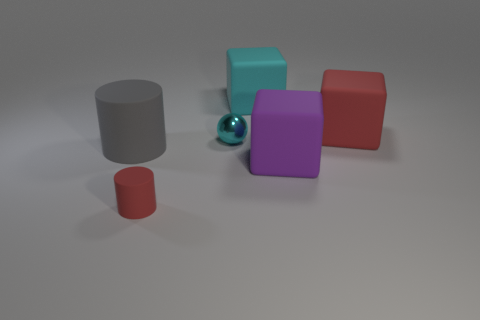What shapes are visible in the scene? The shapes visible include a sphere, cylinders, and cubes. 